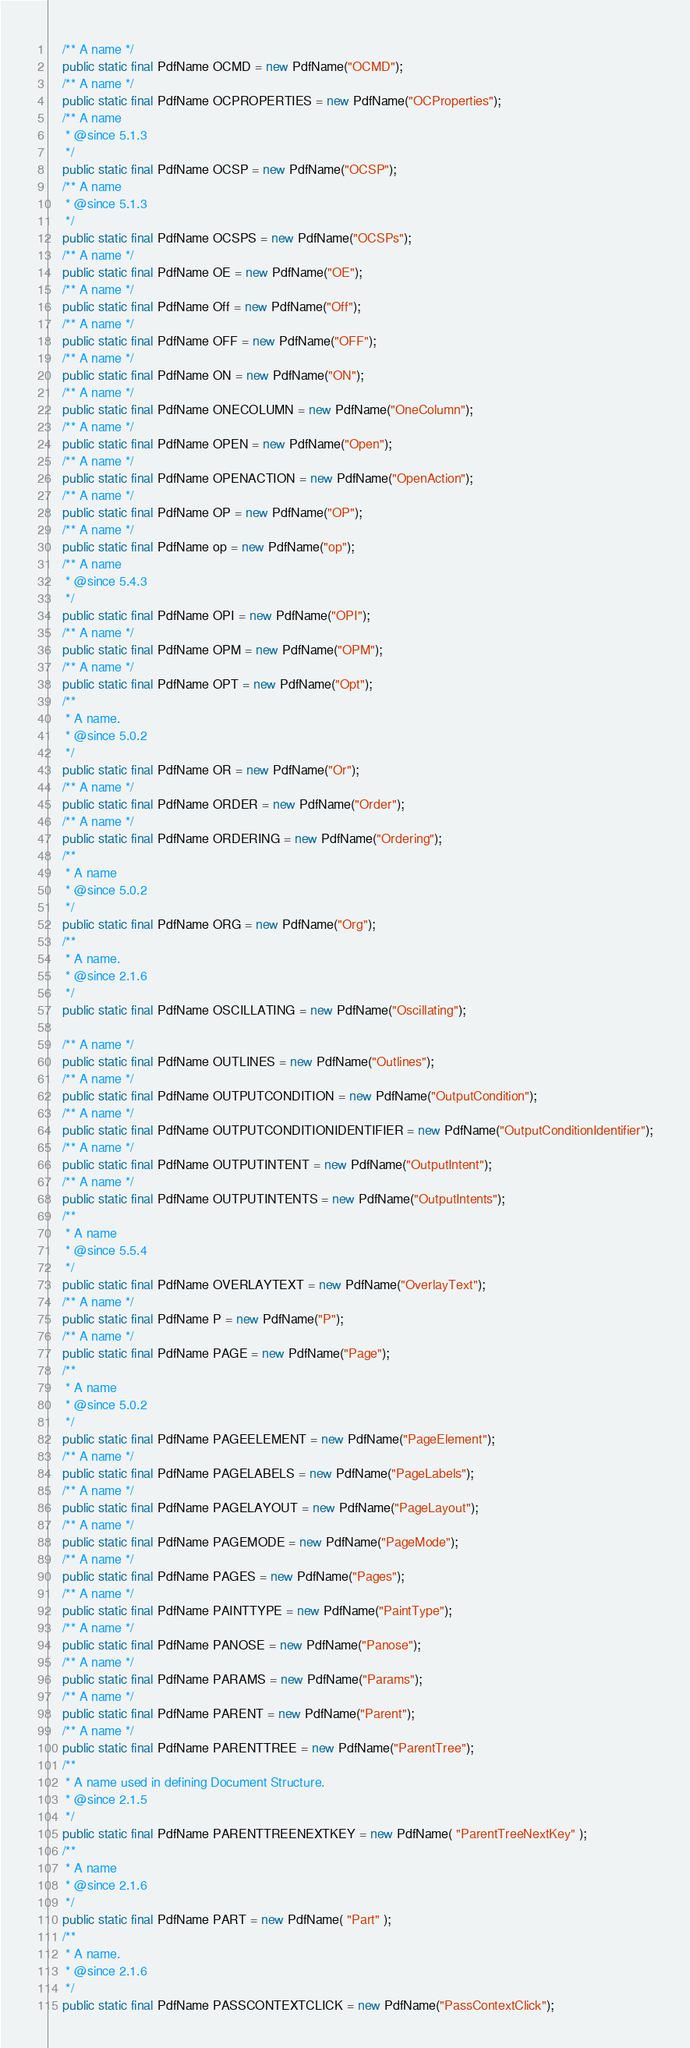Convert code to text. <code><loc_0><loc_0><loc_500><loc_500><_Java_>    /** A name */
    public static final PdfName OCMD = new PdfName("OCMD");
    /** A name */
    public static final PdfName OCPROPERTIES = new PdfName("OCProperties");
    /** A name
     * @since 5.1.3
     */
    public static final PdfName OCSP = new PdfName("OCSP");
    /** A name
     * @since 5.1.3
     */
    public static final PdfName OCSPS = new PdfName("OCSPs");
    /** A name */
    public static final PdfName OE = new PdfName("OE");
    /** A name */
    public static final PdfName Off = new PdfName("Off");
    /** A name */
    public static final PdfName OFF = new PdfName("OFF");
    /** A name */
    public static final PdfName ON = new PdfName("ON");
    /** A name */
    public static final PdfName ONECOLUMN = new PdfName("OneColumn");
    /** A name */
    public static final PdfName OPEN = new PdfName("Open");
    /** A name */
    public static final PdfName OPENACTION = new PdfName("OpenAction");
    /** A name */
    public static final PdfName OP = new PdfName("OP");
    /** A name */
    public static final PdfName op = new PdfName("op");
    /** A name
     * @since 5.4.3
     */
    public static final PdfName OPI = new PdfName("OPI");
    /** A name */
    public static final PdfName OPM = new PdfName("OPM");
    /** A name */
    public static final PdfName OPT = new PdfName("Opt");
    /**
     * A name.
     * @since 5.0.2
     */
    public static final PdfName OR = new PdfName("Or");
    /** A name */
    public static final PdfName ORDER = new PdfName("Order");
    /** A name */
    public static final PdfName ORDERING = new PdfName("Ordering");
    /**
     * A name
     * @since 5.0.2
     */
    public static final PdfName ORG = new PdfName("Org");
    /**
     * A name.
     * @since 2.1.6
     */
    public static final PdfName OSCILLATING = new PdfName("Oscillating");

    /** A name */
    public static final PdfName OUTLINES = new PdfName("Outlines");
    /** A name */
    public static final PdfName OUTPUTCONDITION = new PdfName("OutputCondition");
    /** A name */
    public static final PdfName OUTPUTCONDITIONIDENTIFIER = new PdfName("OutputConditionIdentifier");
    /** A name */
    public static final PdfName OUTPUTINTENT = new PdfName("OutputIntent");
    /** A name */
    public static final PdfName OUTPUTINTENTS = new PdfName("OutputIntents");
    /**
     * A name
     * @since 5.5.4
     */
    public static final PdfName OVERLAYTEXT = new PdfName("OverlayText");
    /** A name */
    public static final PdfName P = new PdfName("P");
    /** A name */
    public static final PdfName PAGE = new PdfName("Page");
    /**
     * A name
     * @since 5.0.2
     */
    public static final PdfName PAGEELEMENT = new PdfName("PageElement");
    /** A name */
    public static final PdfName PAGELABELS = new PdfName("PageLabels");
    /** A name */
    public static final PdfName PAGELAYOUT = new PdfName("PageLayout");
    /** A name */
    public static final PdfName PAGEMODE = new PdfName("PageMode");
    /** A name */
    public static final PdfName PAGES = new PdfName("Pages");
    /** A name */
    public static final PdfName PAINTTYPE = new PdfName("PaintType");
    /** A name */
    public static final PdfName PANOSE = new PdfName("Panose");
    /** A name */
    public static final PdfName PARAMS = new PdfName("Params");
    /** A name */
    public static final PdfName PARENT = new PdfName("Parent");
    /** A name */
    public static final PdfName PARENTTREE = new PdfName("ParentTree");
    /**
     * A name used in defining Document Structure.
     * @since 2.1.5
     */
    public static final PdfName PARENTTREENEXTKEY = new PdfName( "ParentTreeNextKey" );
    /**
     * A name
     * @since 2.1.6
     */
    public static final PdfName PART = new PdfName( "Part" );
    /**
     * A name.
     * @since 2.1.6
     */
    public static final PdfName PASSCONTEXTCLICK = new PdfName("PassContextClick");</code> 